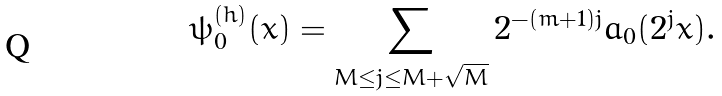<formula> <loc_0><loc_0><loc_500><loc_500>\psi _ { 0 } ^ { ( h ) } ( x ) = \sum _ { M \leq j \leq M + \sqrt { M } } 2 ^ { - ( m + 1 ) j } a _ { 0 } ( 2 ^ { j } x ) .</formula> 